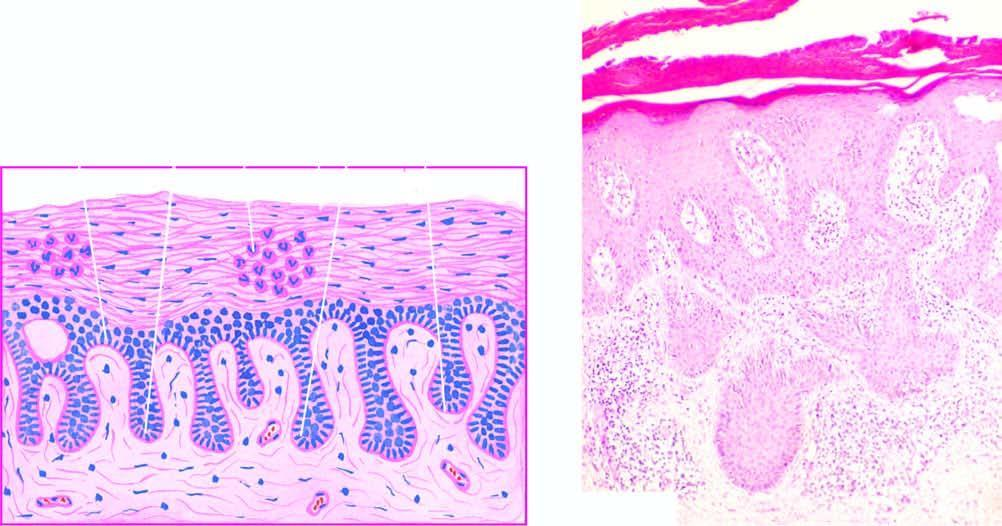s there marked parakeratosis with diagnostic munro microabscesses in the parakeratotic layer?
Answer the question using a single word or phrase. Yes 